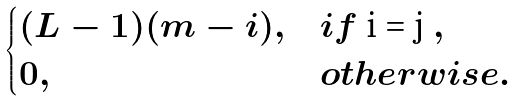<formula> <loc_0><loc_0><loc_500><loc_500>\begin{cases} ( L - 1 ) ( m - i ) , & i f $ i = j $ , \\ 0 , & o t h e r w i s e . \end{cases}</formula> 